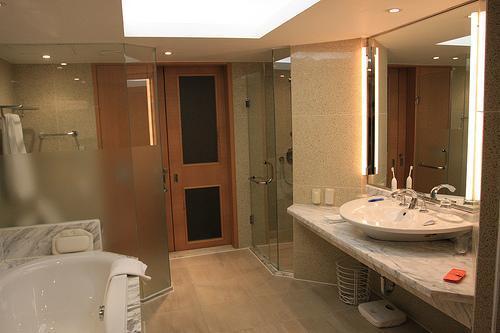How many toothbrushes are there?
Give a very brief answer. 1. 